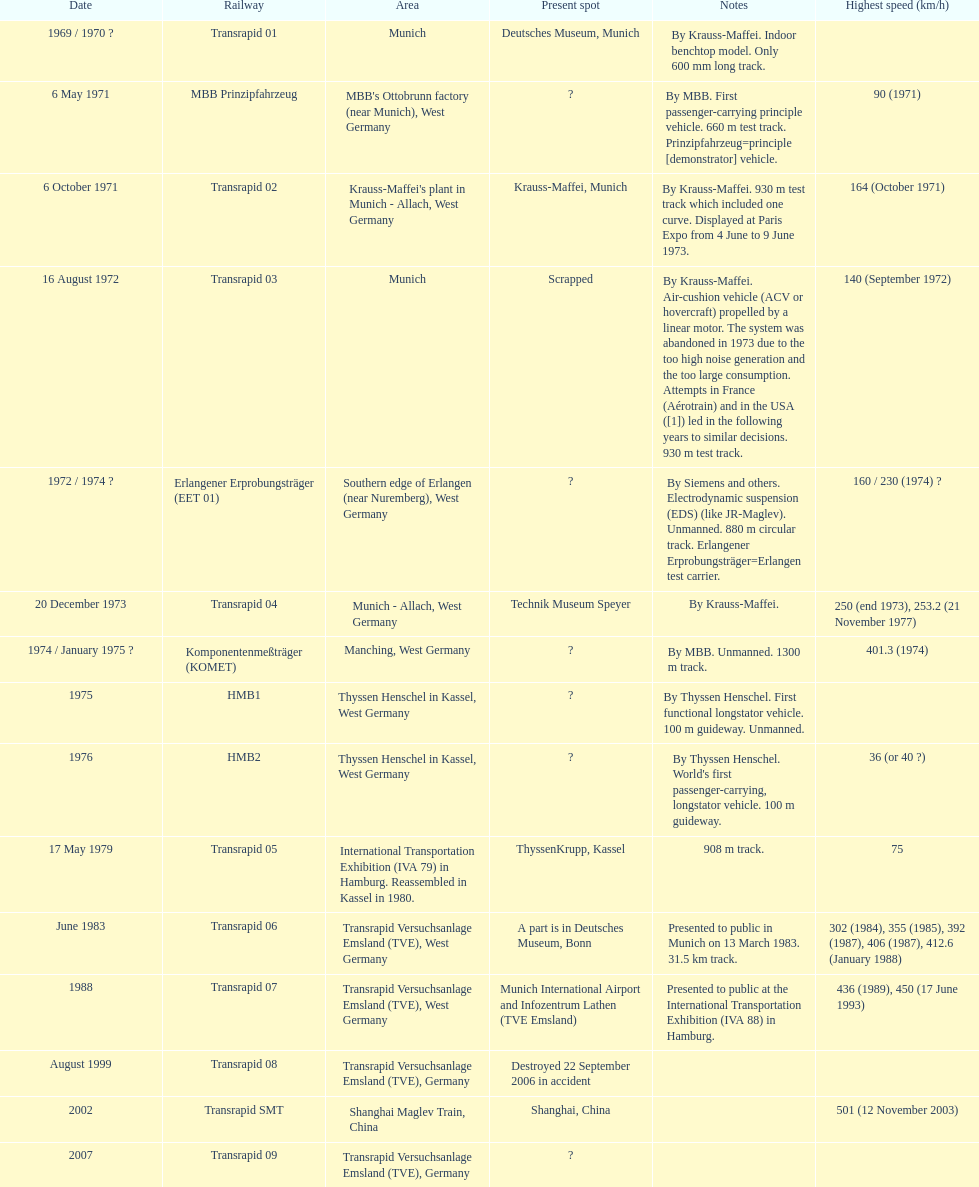Write the full table. {'header': ['Date', 'Railway', 'Area', 'Present spot', 'Notes', 'Highest speed (km/h)'], 'rows': [['1969 / 1970\xa0?', 'Transrapid 01', 'Munich', 'Deutsches Museum, Munich', 'By Krauss-Maffei. Indoor benchtop model. Only 600\xa0mm long track.', ''], ['6 May 1971', 'MBB Prinzipfahrzeug', "MBB's Ottobrunn factory (near Munich), West Germany", '?', 'By MBB. First passenger-carrying principle vehicle. 660 m test track. Prinzipfahrzeug=principle [demonstrator] vehicle.', '90 (1971)'], ['6 October 1971', 'Transrapid 02', "Krauss-Maffei's plant in Munich - Allach, West Germany", 'Krauss-Maffei, Munich', 'By Krauss-Maffei. 930 m test track which included one curve. Displayed at Paris Expo from 4 June to 9 June 1973.', '164 (October 1971)'], ['16 August 1972', 'Transrapid 03', 'Munich', 'Scrapped', 'By Krauss-Maffei. Air-cushion vehicle (ACV or hovercraft) propelled by a linear motor. The system was abandoned in 1973 due to the too high noise generation and the too large consumption. Attempts in France (Aérotrain) and in the USA ([1]) led in the following years to similar decisions. 930 m test track.', '140 (September 1972)'], ['1972 / 1974\xa0?', 'Erlangener Erprobungsträger (EET 01)', 'Southern edge of Erlangen (near Nuremberg), West Germany', '?', 'By Siemens and others. Electrodynamic suspension (EDS) (like JR-Maglev). Unmanned. 880 m circular track. Erlangener Erprobungsträger=Erlangen test carrier.', '160 / 230 (1974)\xa0?'], ['20 December 1973', 'Transrapid 04', 'Munich - Allach, West Germany', 'Technik Museum Speyer', 'By Krauss-Maffei.', '250 (end 1973), 253.2 (21 November 1977)'], ['1974 / January 1975\xa0?', 'Komponentenmeßträger (KOMET)', 'Manching, West Germany', '?', 'By MBB. Unmanned. 1300 m track.', '401.3 (1974)'], ['1975', 'HMB1', 'Thyssen Henschel in Kassel, West Germany', '?', 'By Thyssen Henschel. First functional longstator vehicle. 100 m guideway. Unmanned.', ''], ['1976', 'HMB2', 'Thyssen Henschel in Kassel, West Germany', '?', "By Thyssen Henschel. World's first passenger-carrying, longstator vehicle. 100 m guideway.", '36 (or 40\xa0?)'], ['17 May 1979', 'Transrapid 05', 'International Transportation Exhibition (IVA 79) in Hamburg. Reassembled in Kassel in 1980.', 'ThyssenKrupp, Kassel', '908 m track.', '75'], ['June 1983', 'Transrapid 06', 'Transrapid Versuchsanlage Emsland (TVE), West Germany', 'A part is in Deutsches Museum, Bonn', 'Presented to public in Munich on 13 March 1983. 31.5\xa0km track.', '302 (1984), 355 (1985), 392 (1987), 406 (1987), 412.6 (January 1988)'], ['1988', 'Transrapid 07', 'Transrapid Versuchsanlage Emsland (TVE), West Germany', 'Munich International Airport and Infozentrum Lathen (TVE Emsland)', 'Presented to public at the International Transportation Exhibition (IVA 88) in Hamburg.', '436 (1989), 450 (17 June 1993)'], ['August 1999', 'Transrapid 08', 'Transrapid Versuchsanlage Emsland (TVE), Germany', 'Destroyed 22 September 2006 in accident', '', ''], ['2002', 'Transrapid SMT', 'Shanghai Maglev Train, China', 'Shanghai, China', '', '501 (12 November 2003)'], ['2007', 'Transrapid 09', 'Transrapid Versuchsanlage Emsland (TVE), Germany', '?', '', '']]} How many trains listed have the same speed as the hmb2? 0. 